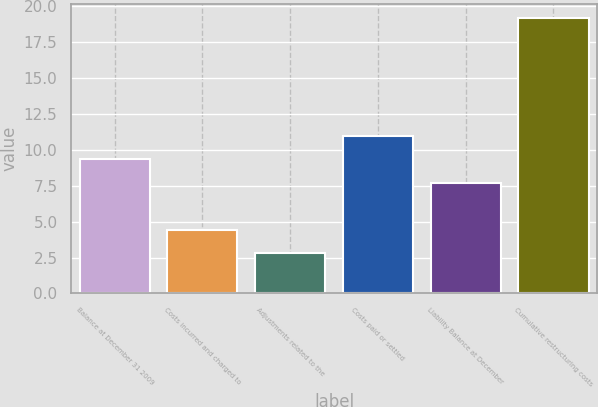Convert chart to OTSL. <chart><loc_0><loc_0><loc_500><loc_500><bar_chart><fcel>Balance at December 31 2009<fcel>Costs incurred and charged to<fcel>Adjustments related to the<fcel>Costs paid or settled<fcel>Liability Balance at December<fcel>Cumulative restructuring costs<nl><fcel>9.36<fcel>4.44<fcel>2.8<fcel>11<fcel>7.72<fcel>19.2<nl></chart> 